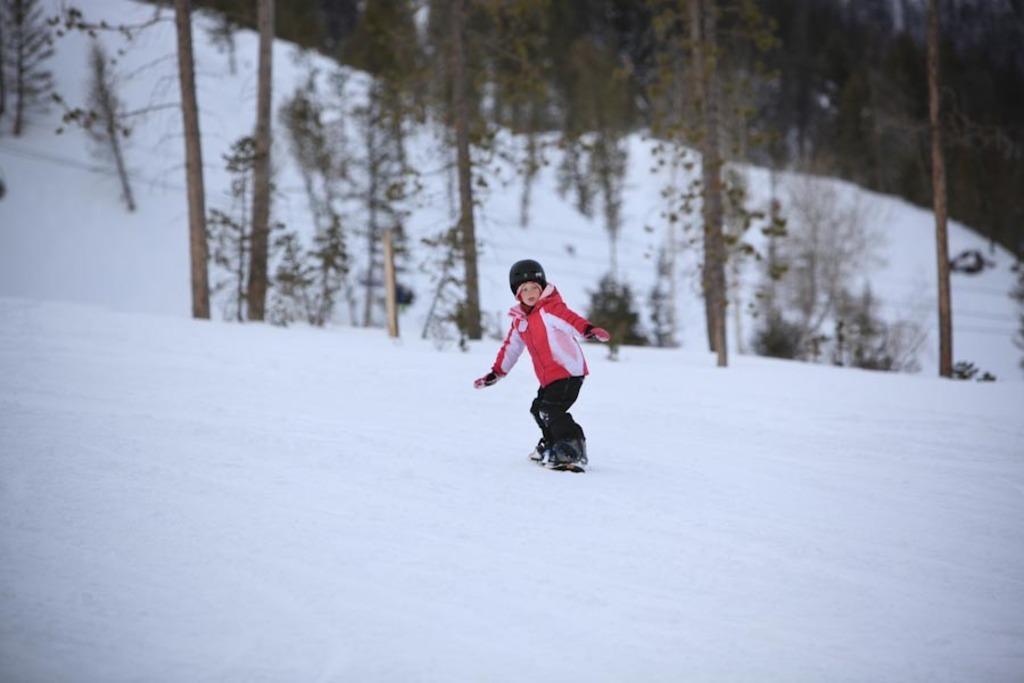In one or two sentences, can you explain what this image depicts? In this image we can see a child wearing sweater, helmet, gloves and shoes is skating on the ice. The background of the image is slightly blurred, where we can see trees and the snow. 